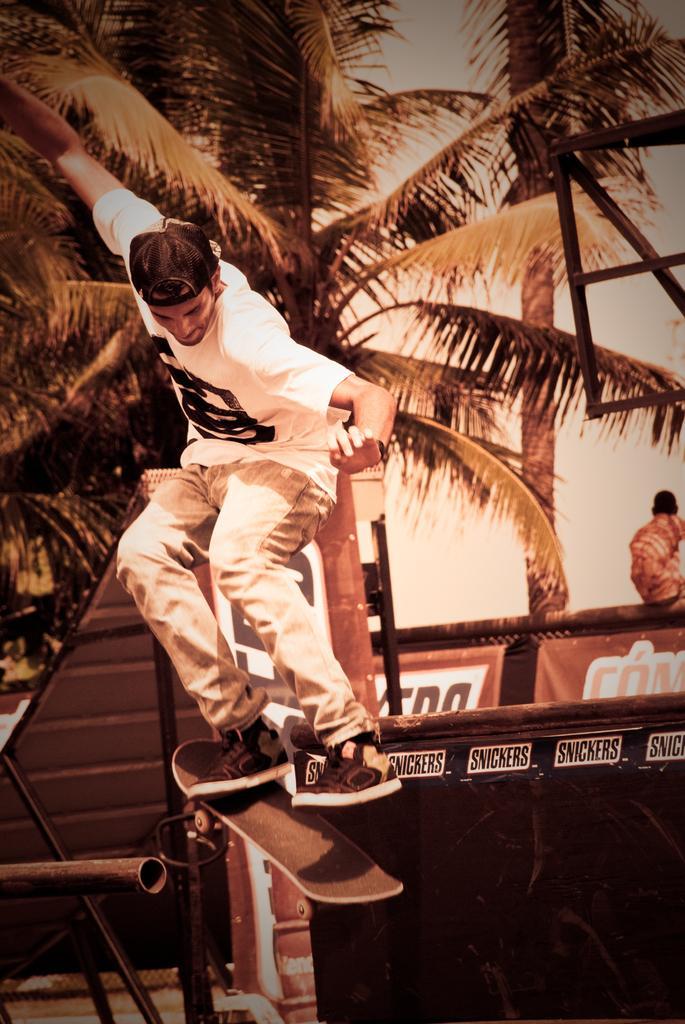How would you summarize this image in a sentence or two? In this image we can see a man is doing skating. He is wearing white color t-shirt with light brown pant and shoes. Background of the image, coconut tree is there. In the right bottom of the image we can see black color barriers and poster. In the left bottom of the image we can see metal rod. 